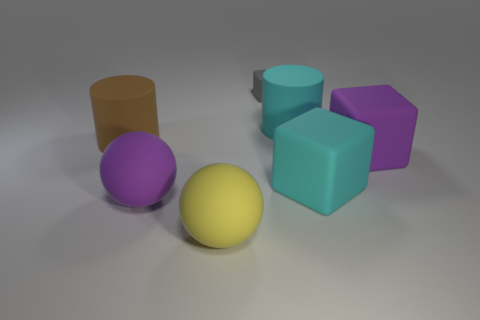There is a purple rubber thing that is on the left side of the cylinder right of the big purple thing to the left of the big purple matte block; what size is it?
Make the answer very short. Large. Does the gray thing have the same material as the large cylinder that is to the right of the yellow object?
Give a very brief answer. Yes. The purple block that is made of the same material as the large brown thing is what size?
Ensure brevity in your answer.  Large. Is there another purple object that has the same shape as the small object?
Ensure brevity in your answer.  Yes. How many things are either cylinders that are on the right side of the large purple rubber ball or large cyan blocks?
Make the answer very short. 2. Do the cylinder that is to the right of the big brown matte object and the big cylinder to the left of the gray rubber thing have the same color?
Your answer should be compact. No. How big is the cyan rubber cylinder?
Provide a succinct answer. Large. What number of small things are either gray blocks or brown objects?
Your answer should be very brief. 1. There is another sphere that is the same size as the yellow matte ball; what is its color?
Provide a succinct answer. Purple. How many other objects are there of the same shape as the brown thing?
Your answer should be very brief. 1. 